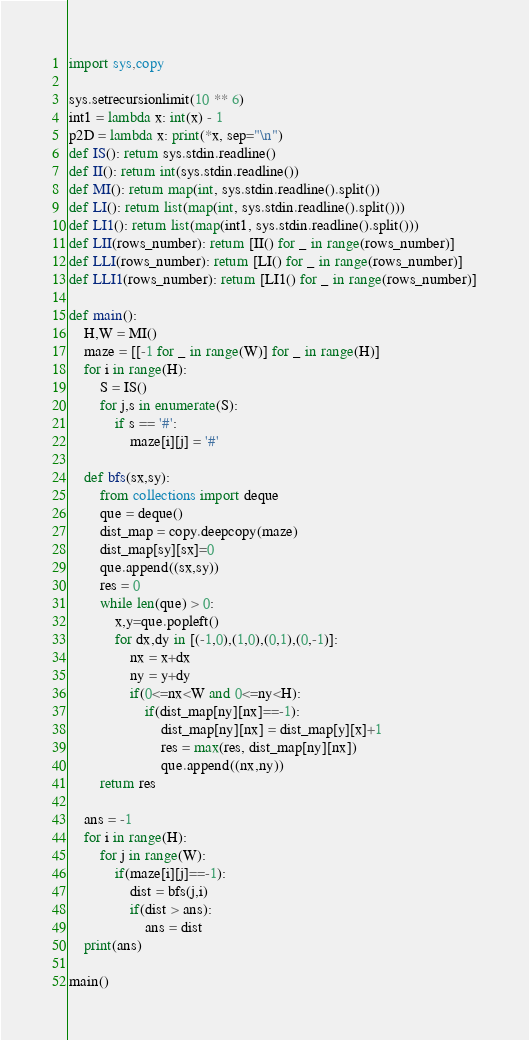Convert code to text. <code><loc_0><loc_0><loc_500><loc_500><_Python_>import sys,copy

sys.setrecursionlimit(10 ** 6)
int1 = lambda x: int(x) - 1
p2D = lambda x: print(*x, sep="\n")
def IS(): return sys.stdin.readline()
def II(): return int(sys.stdin.readline())
def MI(): return map(int, sys.stdin.readline().split())
def LI(): return list(map(int, sys.stdin.readline().split()))
def LI1(): return list(map(int1, sys.stdin.readline().split()))
def LII(rows_number): return [II() for _ in range(rows_number)]
def LLI(rows_number): return [LI() for _ in range(rows_number)]
def LLI1(rows_number): return [LI1() for _ in range(rows_number)]

def main():
	H,W = MI()
	maze = [[-1 for _ in range(W)] for _ in range(H)]
	for i in range(H):
		S = IS()
		for j,s in enumerate(S):
			if s == '#':
				maze[i][j] = '#'

	def bfs(sx,sy):
		from collections import deque
		que = deque()
		dist_map = copy.deepcopy(maze)
		dist_map[sy][sx]=0
		que.append((sx,sy))
		res = 0
		while len(que) > 0:
			x,y=que.popleft()
			for dx,dy in [(-1,0),(1,0),(0,1),(0,-1)]:
				nx = x+dx
				ny = y+dy
				if(0<=nx<W and 0<=ny<H):
					if(dist_map[ny][nx]==-1):
						dist_map[ny][nx] = dist_map[y][x]+1
						res = max(res, dist_map[ny][nx])
						que.append((nx,ny))
		return res

	ans = -1
	for i in range(H):
		for j in range(W):
			if(maze[i][j]==-1):
				dist = bfs(j,i)
				if(dist > ans):
					ans = dist
	print(ans)

main()</code> 